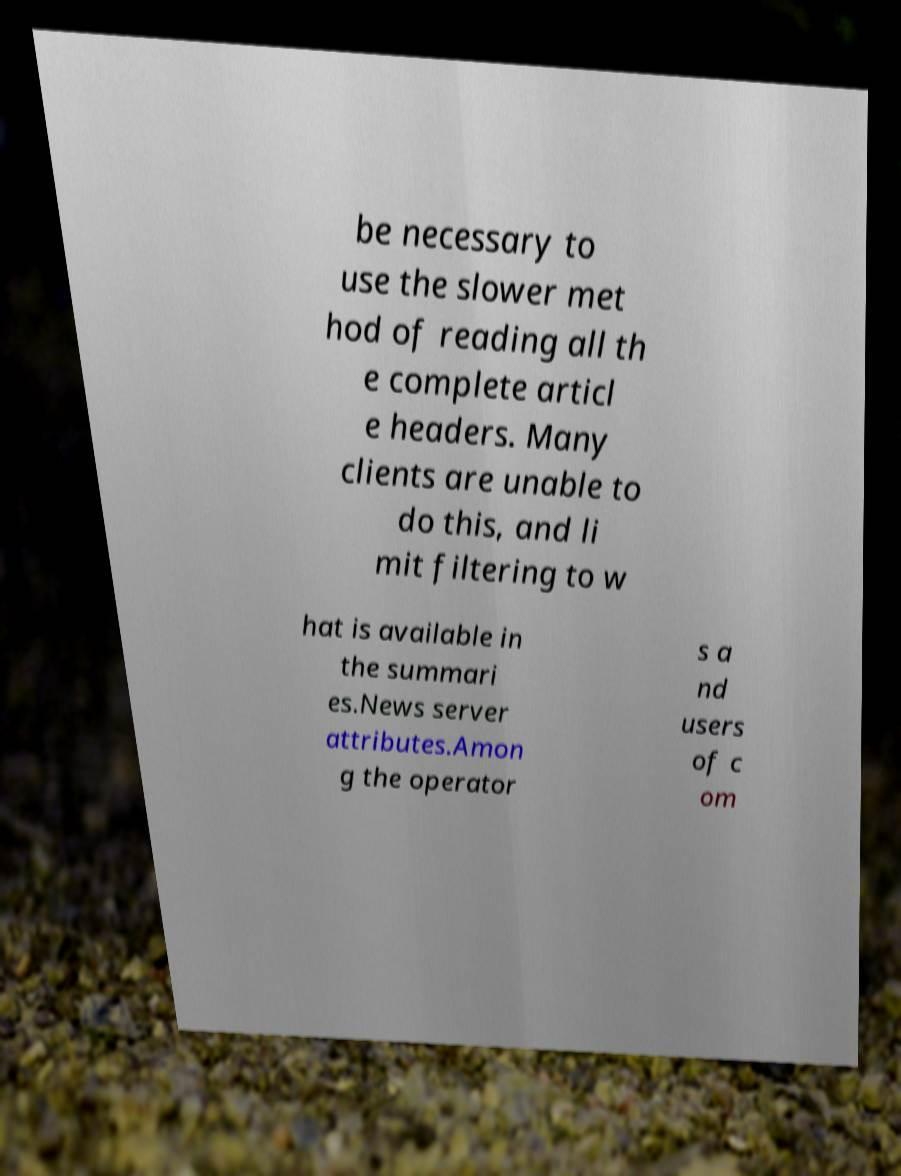For documentation purposes, I need the text within this image transcribed. Could you provide that? be necessary to use the slower met hod of reading all th e complete articl e headers. Many clients are unable to do this, and li mit filtering to w hat is available in the summari es.News server attributes.Amon g the operator s a nd users of c om 